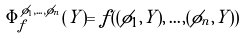Convert formula to latex. <formula><loc_0><loc_0><loc_500><loc_500>\Phi _ { f } ^ { \phi _ { 1 } , \dots , \phi _ { n } } ( Y ) = f ( ( \phi _ { 1 } , Y ) , \dots , ( \phi _ { n } , Y ) )</formula> 